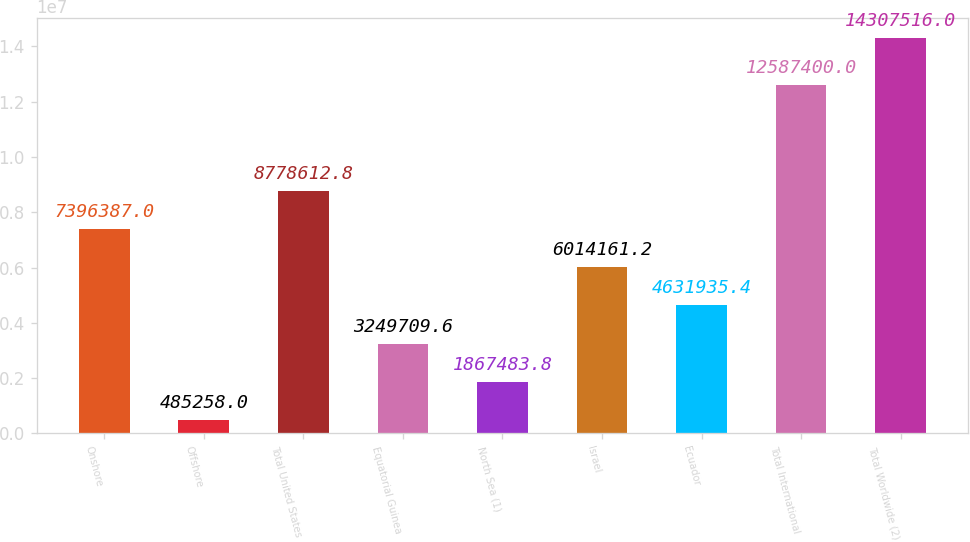Convert chart to OTSL. <chart><loc_0><loc_0><loc_500><loc_500><bar_chart><fcel>Onshore<fcel>Offshore<fcel>Total United States<fcel>Equatorial Guinea<fcel>North Sea (1)<fcel>Israel<fcel>Ecuador<fcel>Total International<fcel>Total Worldwide (2)<nl><fcel>7.39639e+06<fcel>485258<fcel>8.77861e+06<fcel>3.24971e+06<fcel>1.86748e+06<fcel>6.01416e+06<fcel>4.63194e+06<fcel>1.25874e+07<fcel>1.43075e+07<nl></chart> 